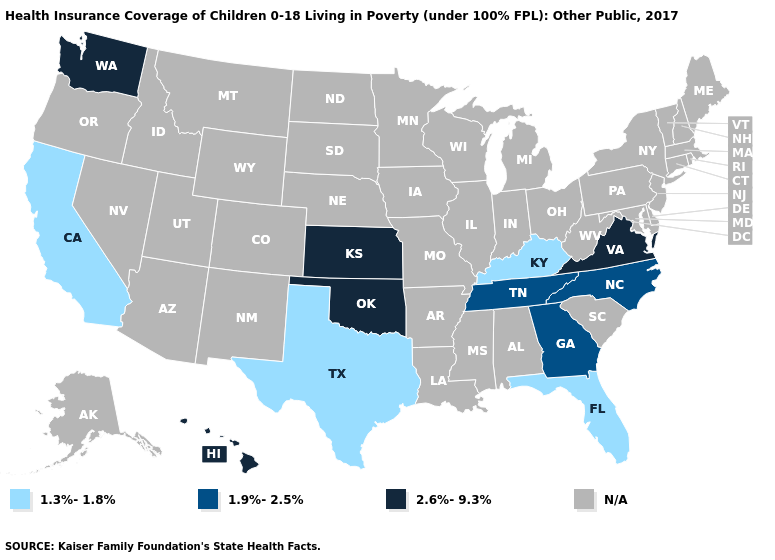Name the states that have a value in the range 2.6%-9.3%?
Be succinct. Hawaii, Kansas, Oklahoma, Virginia, Washington. How many symbols are there in the legend?
Concise answer only. 4. What is the value of Montana?
Keep it brief. N/A. Name the states that have a value in the range N/A?
Give a very brief answer. Alabama, Alaska, Arizona, Arkansas, Colorado, Connecticut, Delaware, Idaho, Illinois, Indiana, Iowa, Louisiana, Maine, Maryland, Massachusetts, Michigan, Minnesota, Mississippi, Missouri, Montana, Nebraska, Nevada, New Hampshire, New Jersey, New Mexico, New York, North Dakota, Ohio, Oregon, Pennsylvania, Rhode Island, South Carolina, South Dakota, Utah, Vermont, West Virginia, Wisconsin, Wyoming. Does the map have missing data?
Keep it brief. Yes. Which states have the lowest value in the USA?
Write a very short answer. California, Florida, Kentucky, Texas. What is the value of Michigan?
Be succinct. N/A. Does the map have missing data?
Keep it brief. Yes. What is the lowest value in the South?
Short answer required. 1.3%-1.8%. What is the value of North Carolina?
Keep it brief. 1.9%-2.5%. Among the states that border Oklahoma , which have the highest value?
Short answer required. Kansas. Name the states that have a value in the range 2.6%-9.3%?
Write a very short answer. Hawaii, Kansas, Oklahoma, Virginia, Washington. 